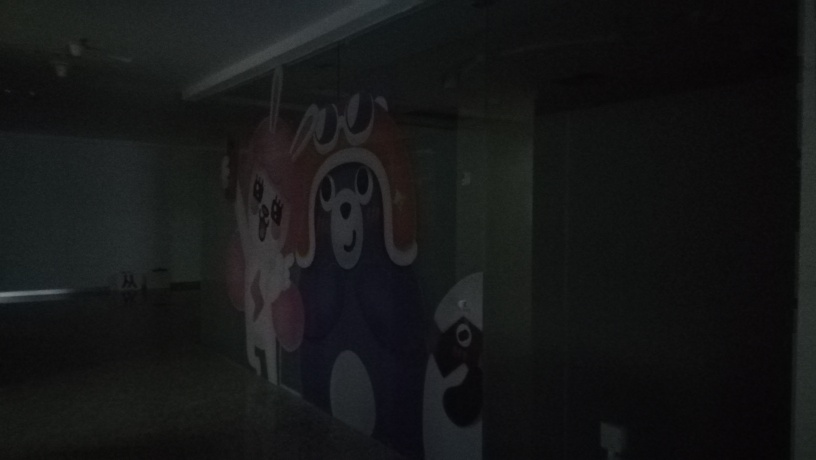What kind of room am I looking at in this image? It appears to be an interior space, likely a part of a building, which is quite dimly lit. The darkness makes it difficult to discern specific uses or contents, but the presence of whimsical wall art suggests it might be a play area or a creative space. 